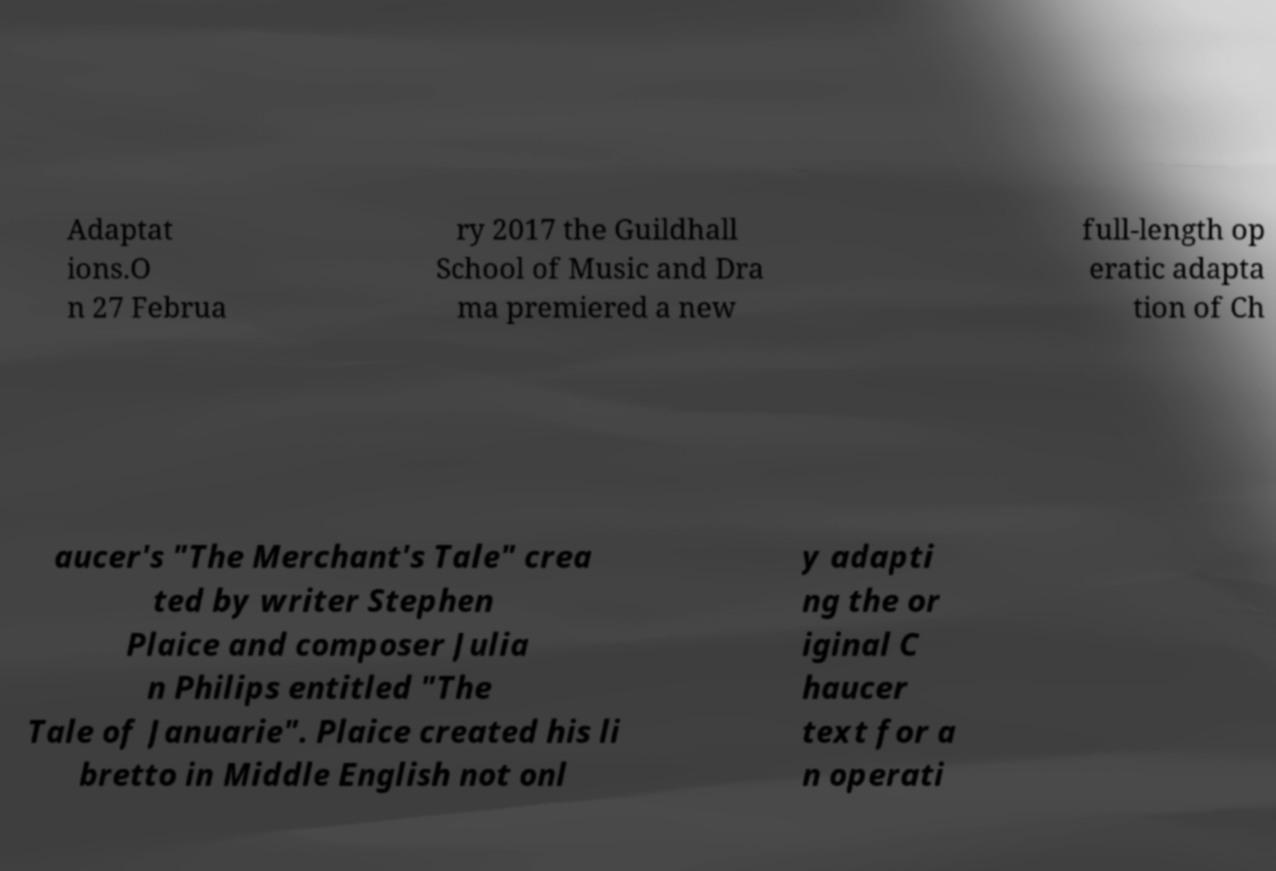What messages or text are displayed in this image? I need them in a readable, typed format. Adaptat ions.O n 27 Februa ry 2017 the Guildhall School of Music and Dra ma premiered a new full-length op eratic adapta tion of Ch aucer's "The Merchant's Tale" crea ted by writer Stephen Plaice and composer Julia n Philips entitled "The Tale of Januarie". Plaice created his li bretto in Middle English not onl y adapti ng the or iginal C haucer text for a n operati 